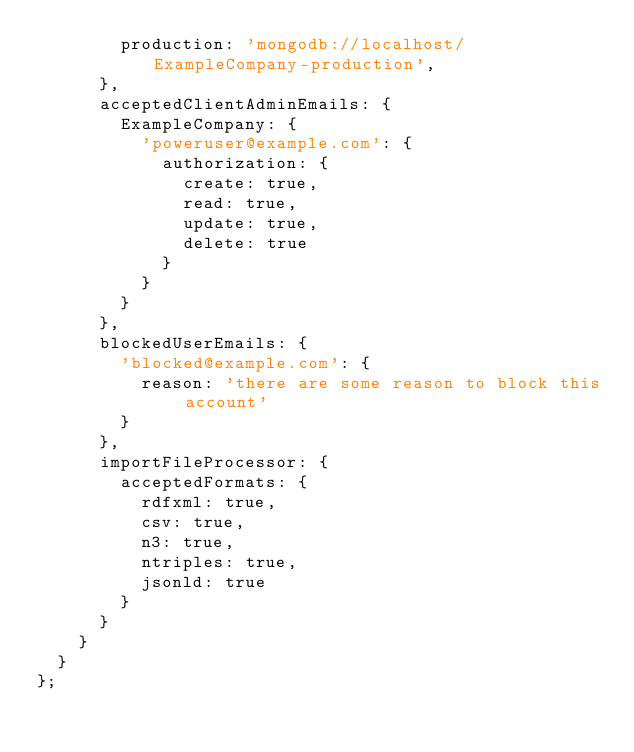<code> <loc_0><loc_0><loc_500><loc_500><_JavaScript_>        production: 'mongodb://localhost/ExampleCompany-production',
      },
      acceptedClientAdminEmails: {
        ExampleCompany: {
          'poweruser@example.com': {
            authorization: {
              create: true,
              read: true,
              update: true,
              delete: true
            }
          }
        }
      },
      blockedUserEmails: {
        'blocked@example.com': {
          reason: 'there are some reason to block this account'
        }
      },
      importFileProcessor: {
        acceptedFormats: {
          rdfxml: true,
          csv: true,
          n3: true,
          ntriples: true,
          jsonld: true
        }
      }
    }
  }
};
</code> 